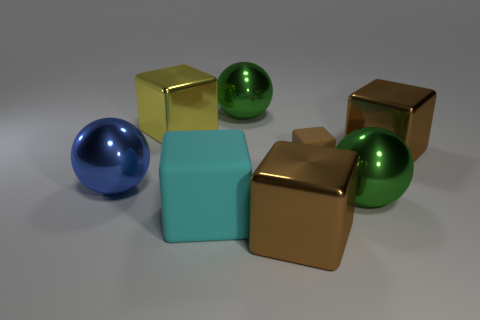Subtract all brown cubes. How many were subtracted if there are1brown cubes left? 2 Subtract all cyan cylinders. How many brown cubes are left? 3 Subtract all cyan cubes. How many cubes are left? 4 Subtract all small brown matte blocks. How many blocks are left? 4 Subtract all green cubes. Subtract all blue balls. How many cubes are left? 5 Add 1 tiny blocks. How many objects exist? 9 Subtract all blocks. How many objects are left? 3 Subtract all cyan spheres. Subtract all big metallic blocks. How many objects are left? 5 Add 2 blue metal balls. How many blue metal balls are left? 3 Add 8 yellow shiny things. How many yellow shiny things exist? 9 